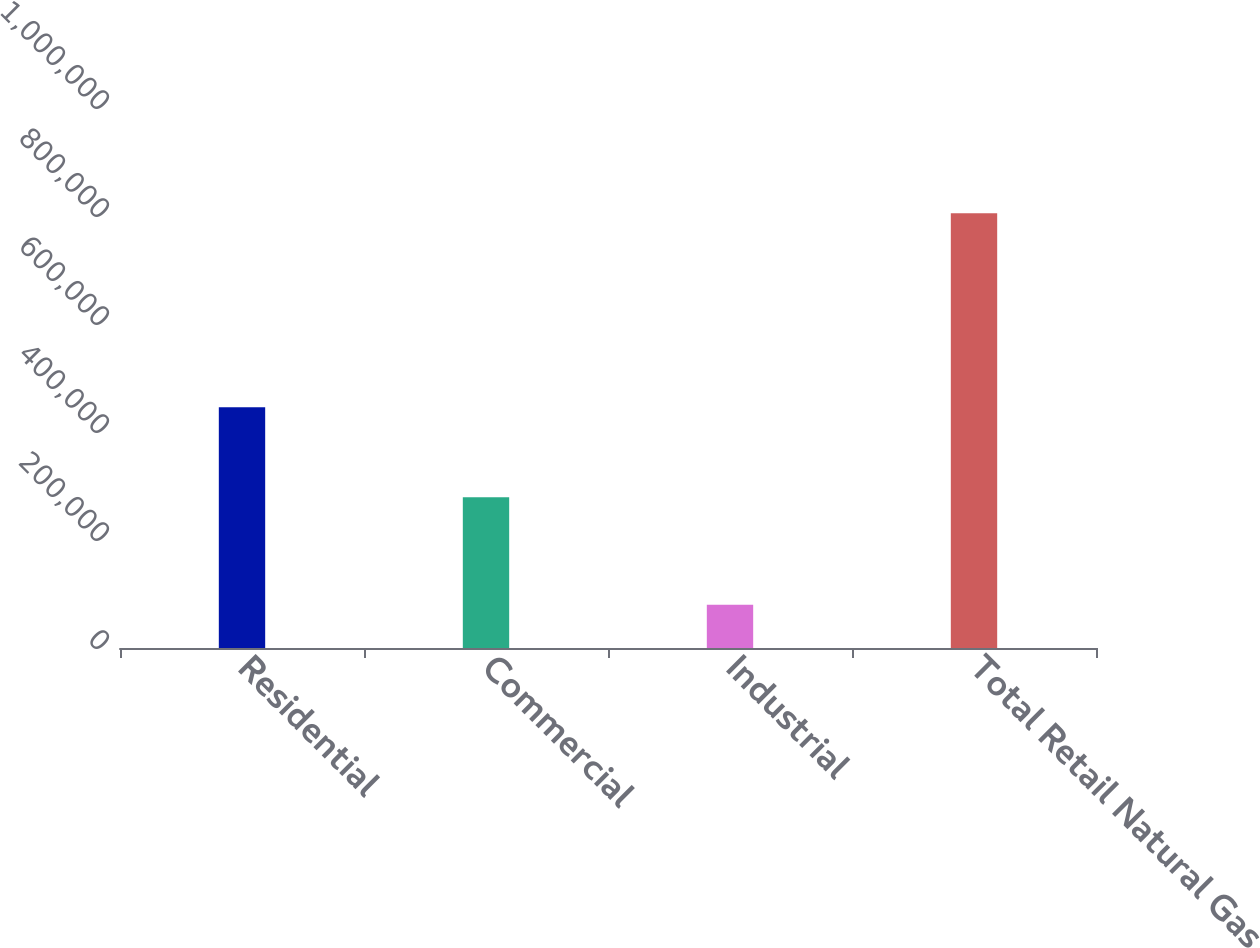Convert chart. <chart><loc_0><loc_0><loc_500><loc_500><bar_chart><fcel>Residential<fcel>Commercial<fcel>Industrial<fcel>Total Retail Natural Gas<nl><fcel>446052<fcel>279001<fcel>80093<fcel>805146<nl></chart> 